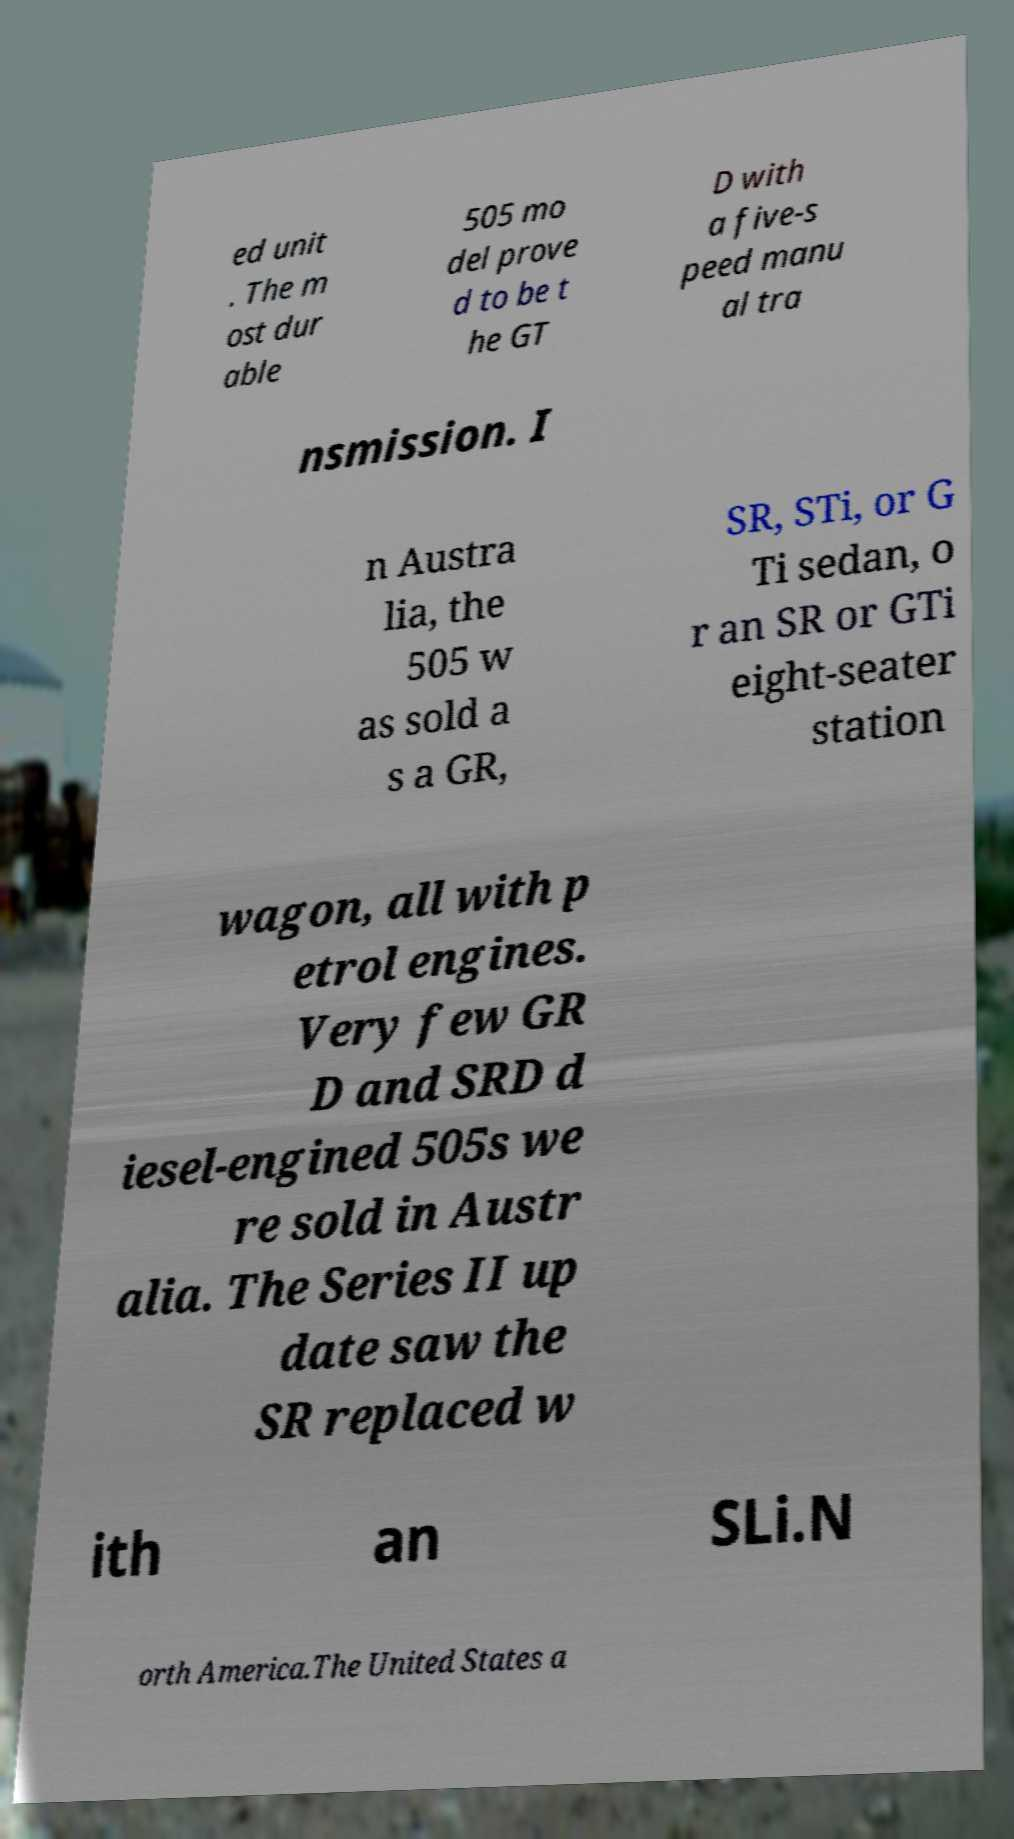Can you accurately transcribe the text from the provided image for me? ed unit . The m ost dur able 505 mo del prove d to be t he GT D with a five-s peed manu al tra nsmission. I n Austra lia, the 505 w as sold a s a GR, SR, STi, or G Ti sedan, o r an SR or GTi eight-seater station wagon, all with p etrol engines. Very few GR D and SRD d iesel-engined 505s we re sold in Austr alia. The Series II up date saw the SR replaced w ith an SLi.N orth America.The United States a 